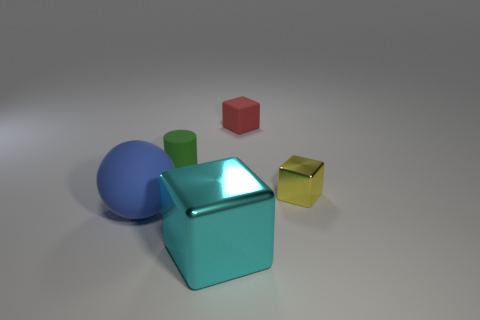Is there any other thing that is the same shape as the green object?
Offer a very short reply. No. Are there any tiny cubes made of the same material as the big cyan object?
Keep it short and to the point. Yes. How many gray matte cylinders are there?
Provide a succinct answer. 0. The cube behind the shiny cube behind the large blue sphere is made of what material?
Make the answer very short. Rubber. There is a sphere that is made of the same material as the small red object; what color is it?
Keep it short and to the point. Blue. Is the size of the block that is behind the cylinder the same as the yellow object on the right side of the green matte cylinder?
Your answer should be compact. Yes. What number of cylinders are large cyan rubber things or red matte objects?
Offer a very short reply. 0. Is the material of the tiny object behind the small green cylinder the same as the yellow object?
Provide a succinct answer. No. How many other things are the same size as the rubber cylinder?
Your response must be concise. 2. How many tiny objects are either red matte objects or purple metallic cubes?
Offer a very short reply. 1. 